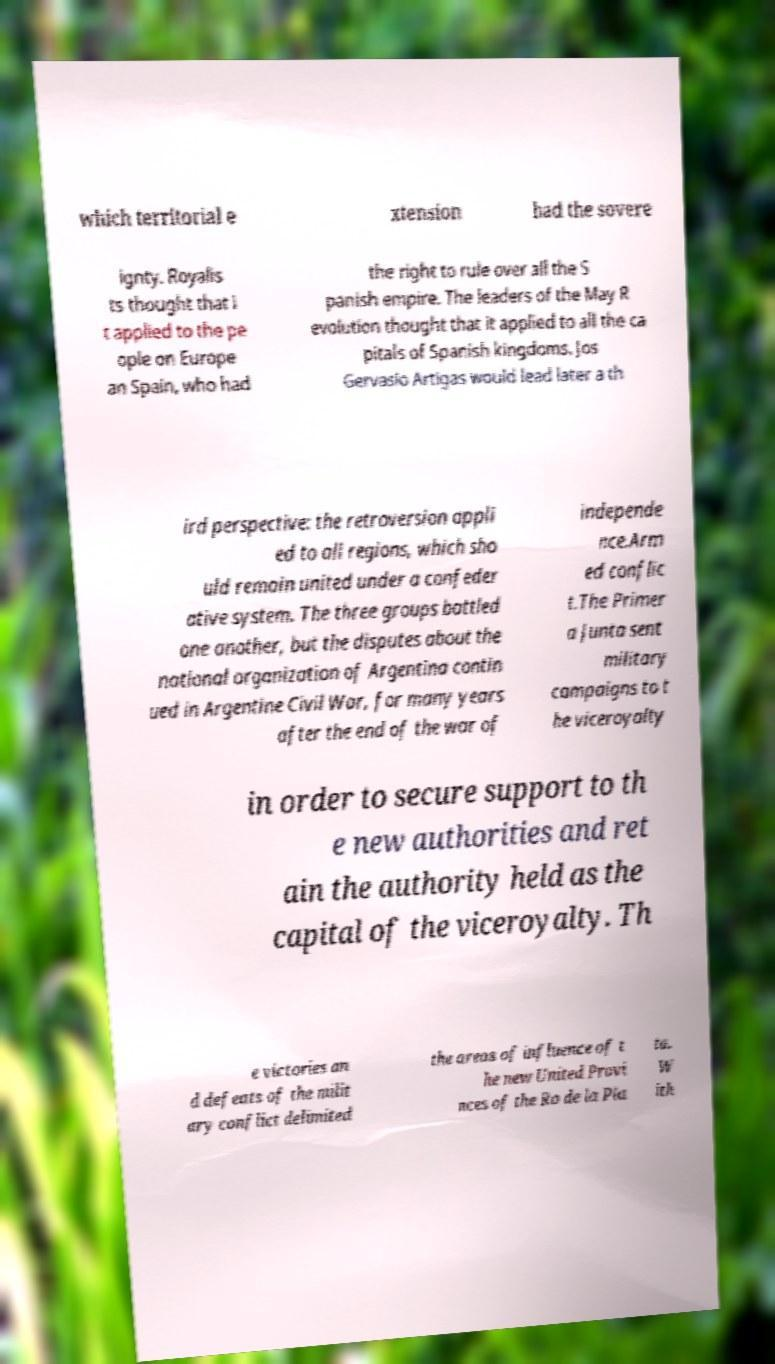Could you assist in decoding the text presented in this image and type it out clearly? which territorial e xtension had the sovere ignty. Royalis ts thought that i t applied to the pe ople on Europe an Spain, who had the right to rule over all the S panish empire. The leaders of the May R evolution thought that it applied to all the ca pitals of Spanish kingdoms. Jos Gervasio Artigas would lead later a th ird perspective: the retroversion appli ed to all regions, which sho uld remain united under a confeder ative system. The three groups battled one another, but the disputes about the national organization of Argentina contin ued in Argentine Civil War, for many years after the end of the war of independe nce.Arm ed conflic t.The Primer a Junta sent military campaigns to t he viceroyalty in order to secure support to th e new authorities and ret ain the authority held as the capital of the viceroyalty. Th e victories an d defeats of the milit ary conflict delimited the areas of influence of t he new United Provi nces of the Ro de la Pla ta. W ith 